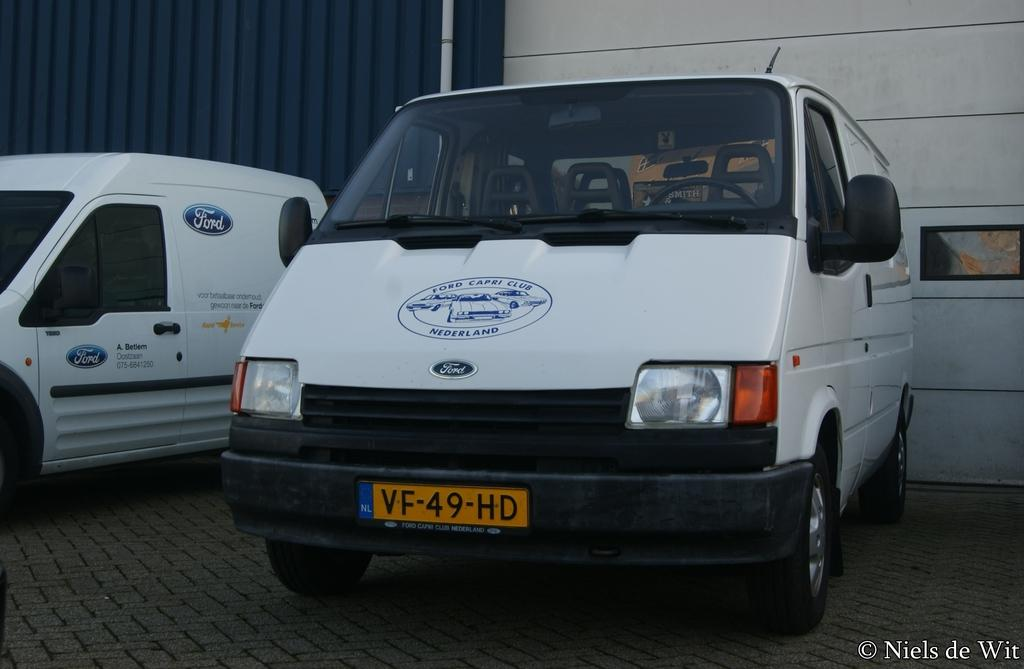<image>
Relay a brief, clear account of the picture shown. Commercial vans for a Nederland Ford dealership sit side by side in front of a blue building. 